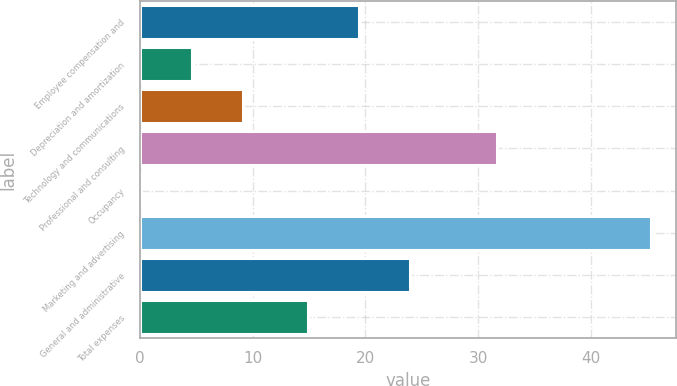Convert chart. <chart><loc_0><loc_0><loc_500><loc_500><bar_chart><fcel>Employee compensation and<fcel>Depreciation and amortization<fcel>Technology and communications<fcel>Professional and consulting<fcel>Occupancy<fcel>Marketing and advertising<fcel>General and administrative<fcel>Total expenses<nl><fcel>19.42<fcel>4.62<fcel>9.14<fcel>31.7<fcel>0.1<fcel>45.3<fcel>23.94<fcel>14.9<nl></chart> 